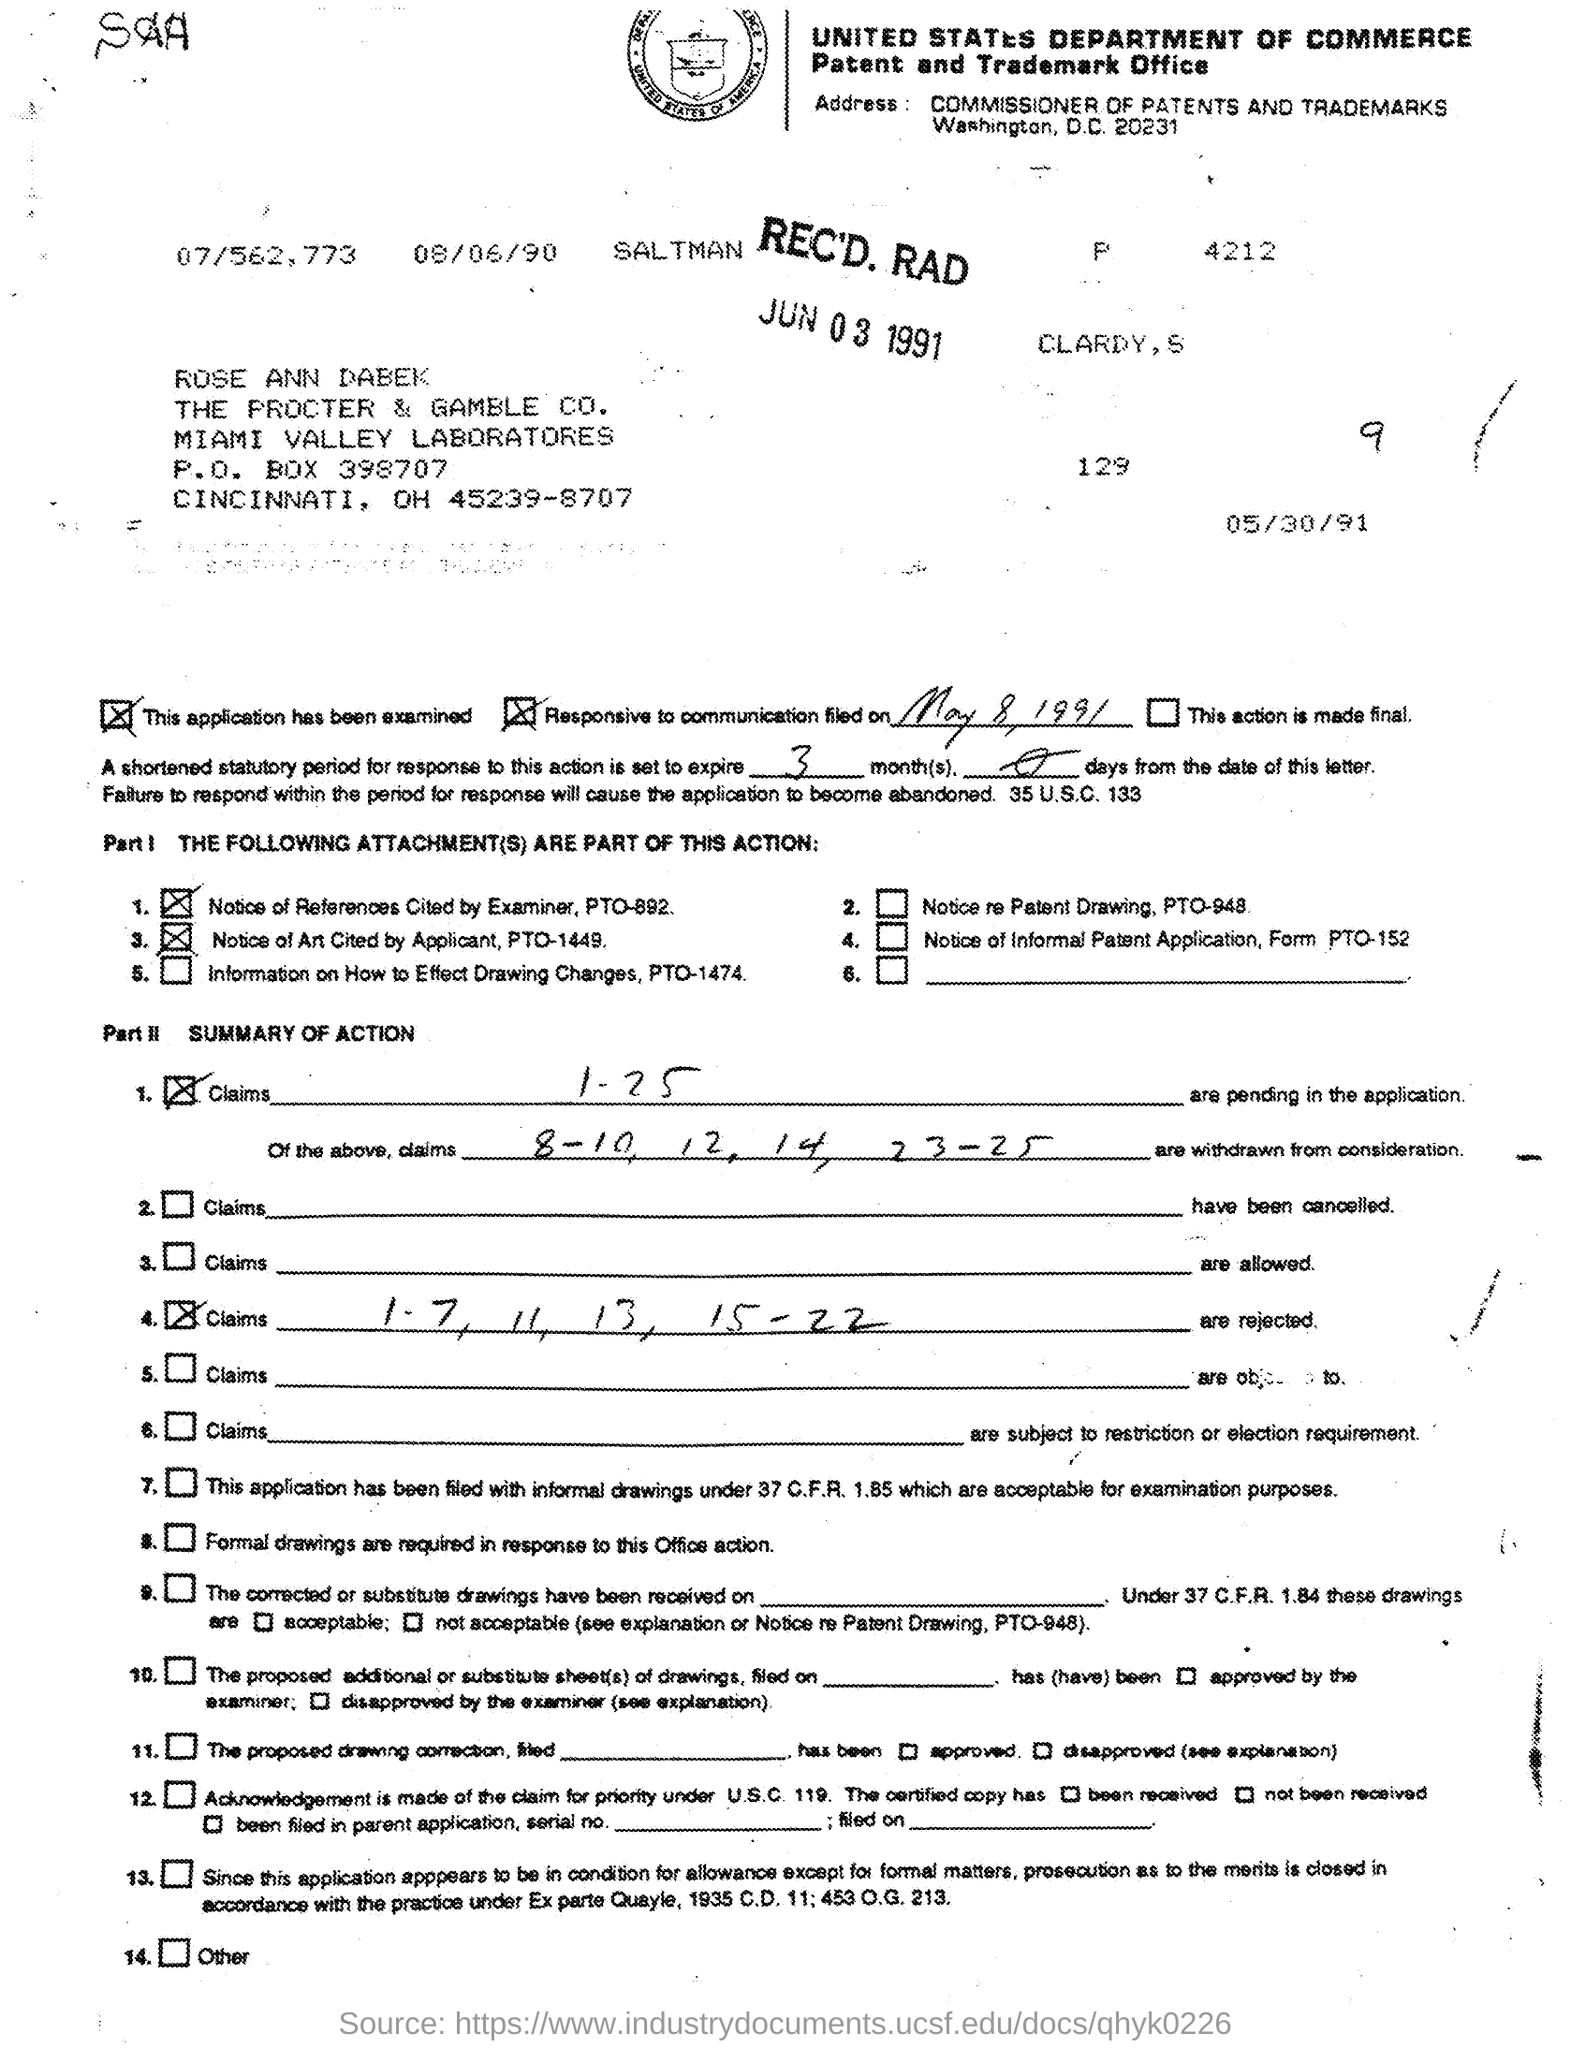Point out several critical features in this image. The communication field was established on May 8, 1991. 